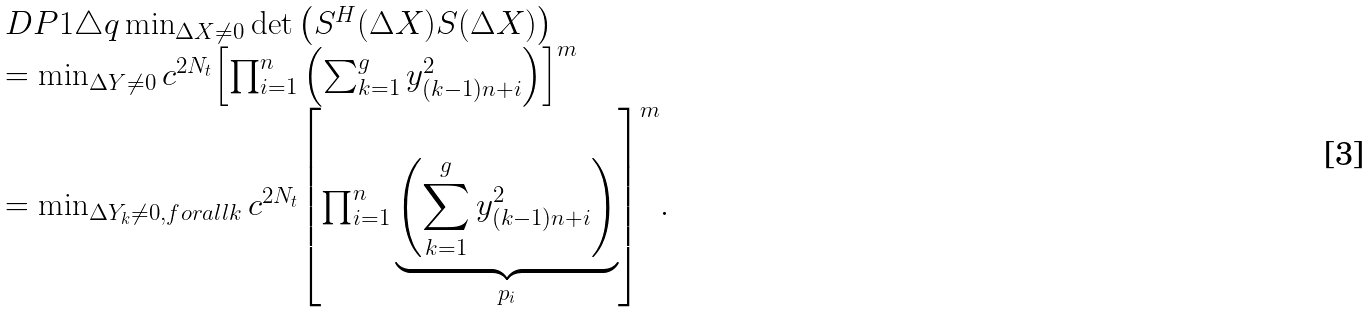<formula> <loc_0><loc_0><loc_500><loc_500>\begin{array} { l } D P 1 \triangle q \min _ { \Delta X \neq 0 } \det \left ( S ^ { H } ( \Delta X ) S ( \Delta X ) \right ) \\ = \min _ { \Delta Y \neq 0 } c ^ { 2 N _ { t } } { \left [ \prod _ { i = 1 } ^ { n } \left ( \sum _ { k = 1 } ^ { g } y _ { ( k - 1 ) n + i } ^ { 2 } \right ) \right ] } ^ { m } \\ = \min _ { \Delta Y _ { k } \neq 0 , f o r a l l k } c ^ { 2 N _ { t } } { \left [ \prod _ { i = 1 } ^ { n } \underbrace { \left ( \sum _ { k = 1 } ^ { g } y _ { ( k - 1 ) n + i } ^ { 2 } \right ) } _ { p _ { i } } \right ] } ^ { m } . \end{array}</formula> 